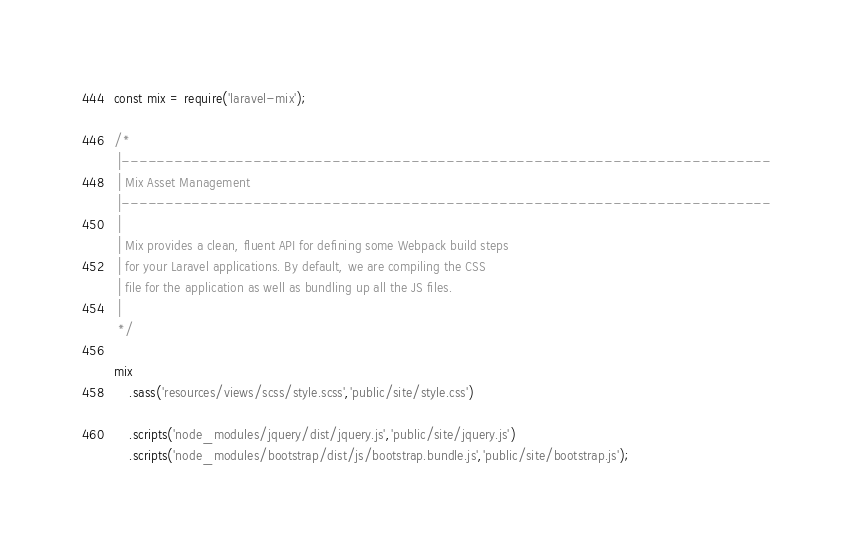Convert code to text. <code><loc_0><loc_0><loc_500><loc_500><_JavaScript_>const mix = require('laravel-mix');

/*
 |--------------------------------------------------------------------------
 | Mix Asset Management
 |--------------------------------------------------------------------------
 |
 | Mix provides a clean, fluent API for defining some Webpack build steps
 | for your Laravel applications. By default, we are compiling the CSS
 | file for the application as well as bundling up all the JS files.
 |
 */

mix
    .sass('resources/views/scss/style.scss','public/site/style.css')

    .scripts('node_modules/jquery/dist/jquery.js','public/site/jquery.js')
    .scripts('node_modules/bootstrap/dist/js/bootstrap.bundle.js','public/site/bootstrap.js');</code> 